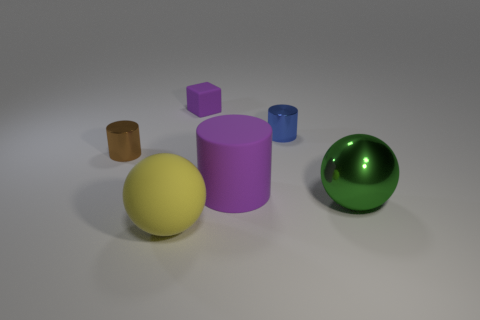Is the number of small purple cubes that are on the right side of the tiny purple block the same as the number of large shiny objects behind the matte cylinder?
Give a very brief answer. Yes. The green ball that is the same material as the brown cylinder is what size?
Provide a short and direct response. Large. What is the color of the big matte sphere?
Your response must be concise. Yellow. How many large objects are the same color as the small matte cube?
Offer a very short reply. 1. There is a green object that is the same size as the purple cylinder; what is it made of?
Offer a terse response. Metal. There is a tiny shiny cylinder behind the tiny brown object; is there a tiny metallic cylinder that is in front of it?
Make the answer very short. Yes. What number of other objects are the same color as the tiny matte object?
Give a very brief answer. 1. How big is the green metallic ball?
Your response must be concise. Large. Are any brown shiny objects visible?
Offer a very short reply. Yes. Is the number of small purple things behind the tiny brown metallic cylinder greater than the number of yellow rubber balls that are to the right of the purple cylinder?
Make the answer very short. Yes. 